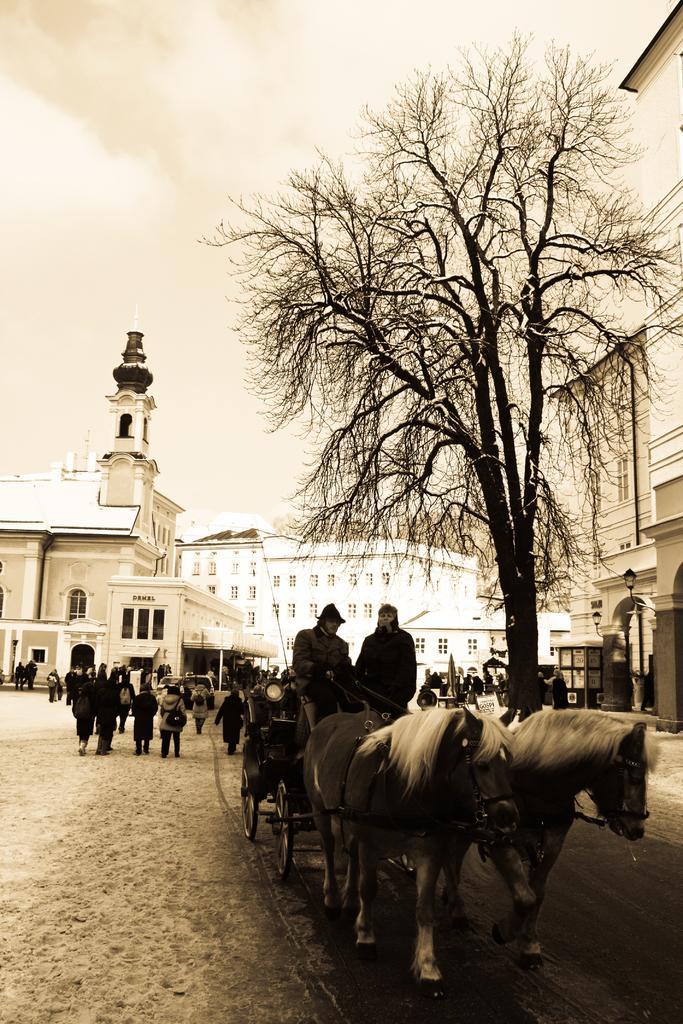In one or two sentences, can you explain what this image depicts? In this image we have a tree and horse cart wheel. There are group of people walking on the road. Behind the people we have a building and sky. 